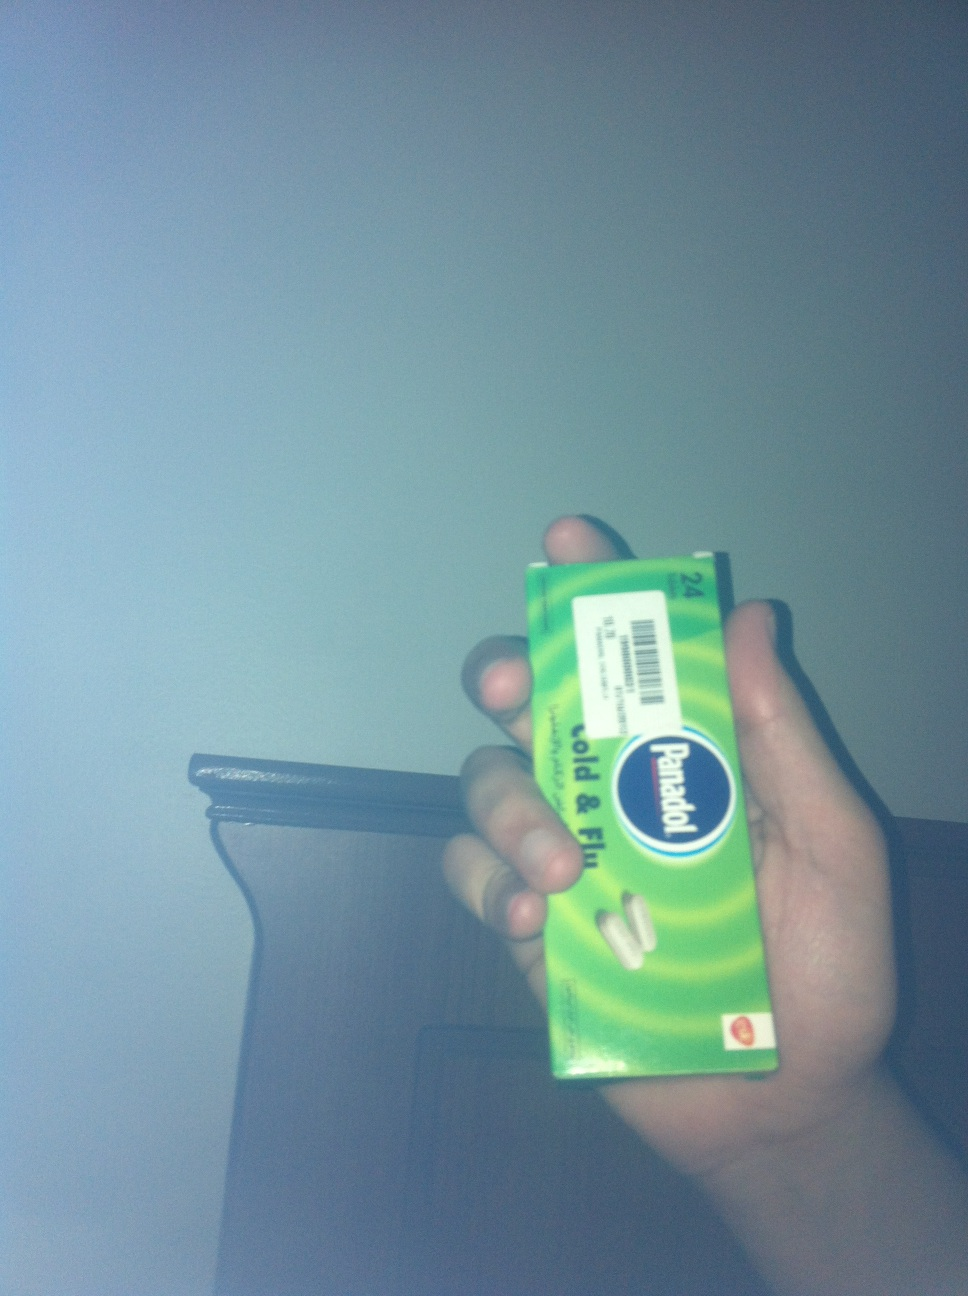How should this medication be stored? This medication should be stored in a cool, dry place away from direct sunlight and moisture. It's important to keep it out of reach of children and to ensure the packaging remains sealed when not in use to maintain its efficacy. 